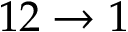Convert formula to latex. <formula><loc_0><loc_0><loc_500><loc_500>1 2 \to 1</formula> 